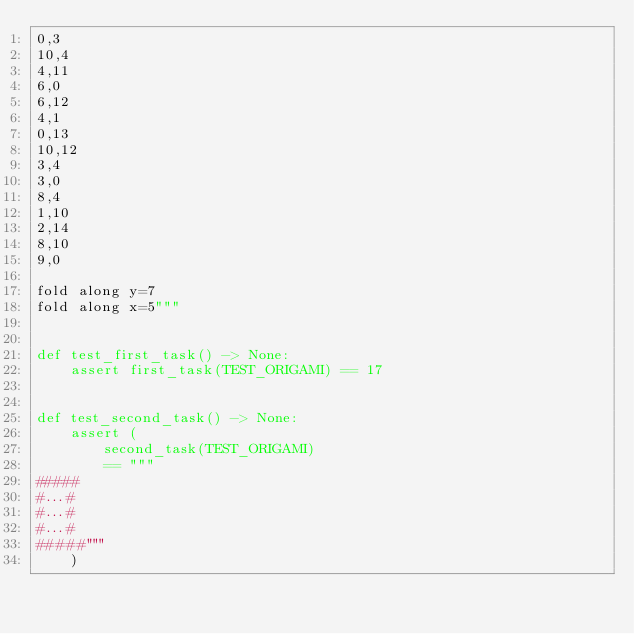Convert code to text. <code><loc_0><loc_0><loc_500><loc_500><_Python_>0,3
10,4
4,11
6,0
6,12
4,1
0,13
10,12
3,4
3,0
8,4
1,10
2,14
8,10
9,0

fold along y=7
fold along x=5"""


def test_first_task() -> None:
    assert first_task(TEST_ORIGAMI) == 17


def test_second_task() -> None:
    assert (
        second_task(TEST_ORIGAMI)
        == """
#####
#...#
#...#
#...#
#####"""
    )
</code> 